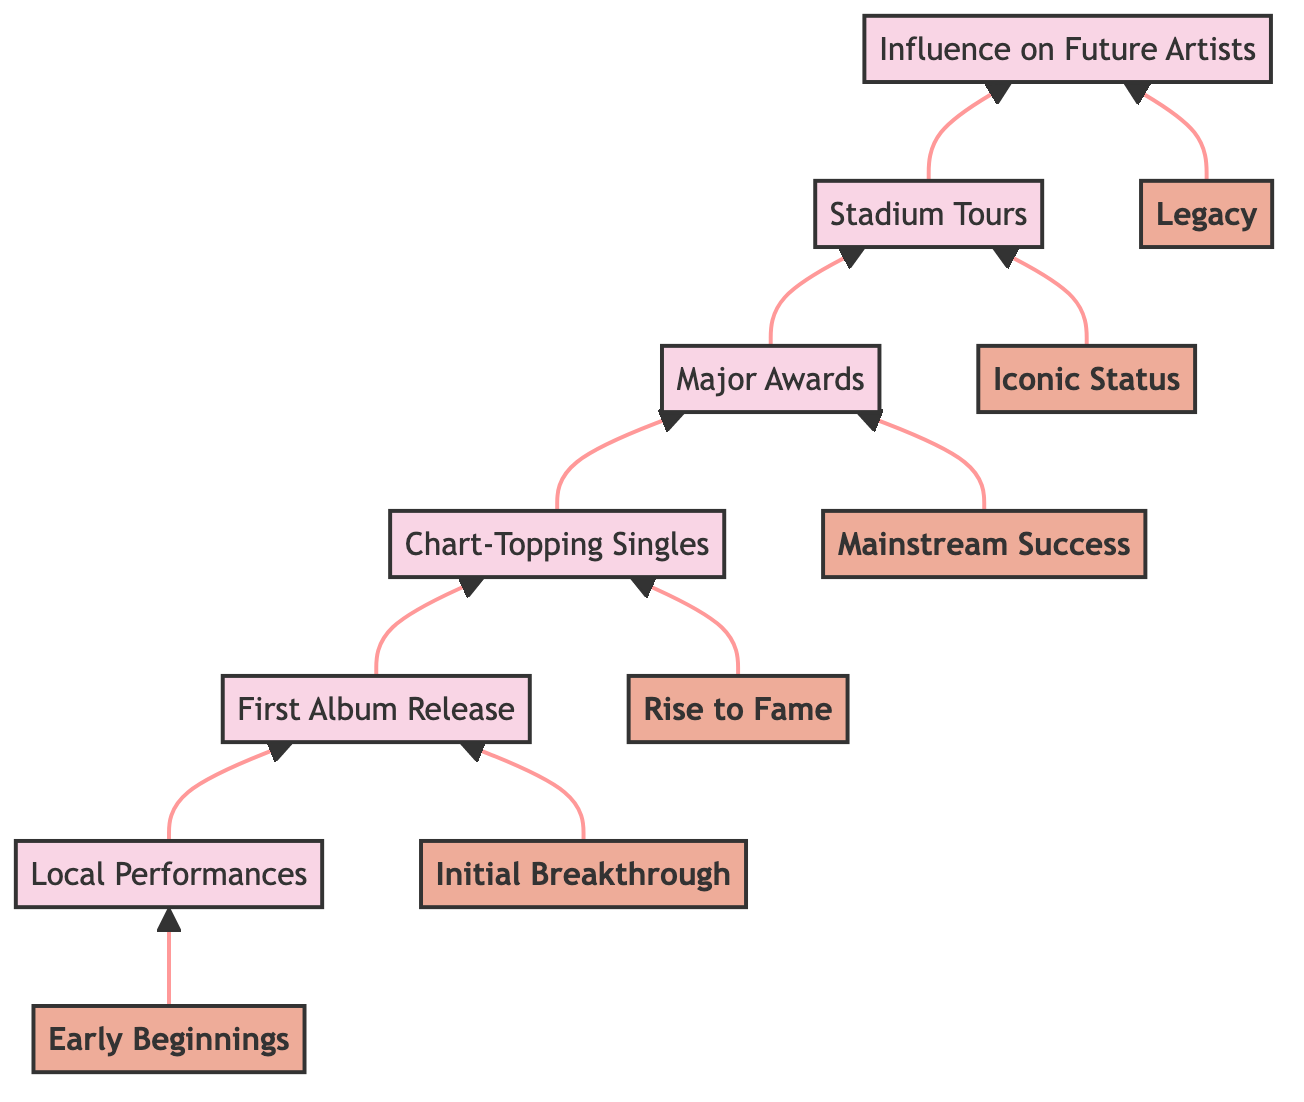What is the topmost level in the diagram? The topmost level is labeled "Legacy," which signifies the final stage of an artist's career evolution in the context of the diagram.
Answer: Legacy How many levels are presented in the diagram? There are six levels, starting from "Early Beginnings" at the bottom and going up to "Legacy" at the top.
Answer: Six What is the first step in the evolution of an artist's career? The diagram indicates that the first step is "Local Performances," where artists begin their career.
Answer: Local Performances Which level corresponds to winning major awards? The level titled "Mainstream Success" is where artists achieve recognition by winning significant awards such as CMA, Grammy, and ACM Awards.
Answer: Mainstream Success What is the relationship between "Stadium Tours" and "Major Awards"? "Stadium Tours" is the next level following "Major Awards," indicating that after winning major awards, artists typically embark on large-scale tours.
Answer: Next Which element influences future artists? The final level "Influence on Future Artists" shows the lasting impact that successful 80s country pop artists have on upcoming musicians in the genre.
Answer: Influence on Future Artists What level follows "Chart-Topping Singles"? The level that follows "Chart-Topping Singles" is "Major Awards," where artists gain further recognition after achieving hit singles.
Answer: Major Awards What is the flow direction of the chart? The flow direction of the chart is upward, indicating a progression in the evolution of artists' careers from bottom to top.
Answer: Upward Identify the level where artists release their first album. The level for releasing their first album is "First Album Release," which is the second step in the progression.
Answer: First Album Release 